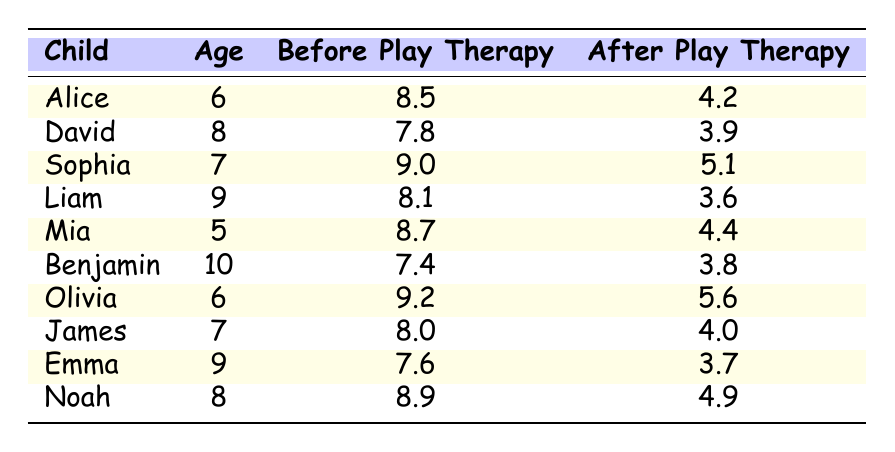What was Alice's stress level before play therapy? Alice's stress level before play therapy is directly listed in the table as 8.5.
Answer: 8.5 What is the stress level of David after play therapy? The stress level after play therapy for David can be found in the "After Play Therapy" column and is noted as 3.9.
Answer: 3.9 Which child had the highest stress level before play therapy? To find the child with the highest stress level before therapy, we can compare the "Before Play Therapy" values. Sophia has the highest value at 9.0.
Answer: Sophia What is the difference in stress levels for Liam before and after play therapy? To calculate the difference, we subtract Liam's "After Play Therapy" value of 3.6 from his "Before Play Therapy" value of 8.1: 8.1 - 3.6 = 4.5.
Answer: 4.5 Is Mia's stress level after play therapy lower than Noah's stress level before play therapy? Mia's stress level after therapy is 4.4, while Noah's stress level before therapy is 8.9. Since 4.4 is less than 8.9, the answer is yes.
Answer: Yes What was the average stress level of all children before play therapy? To find the average, sum all "Before Play Therapy" values (8.5 + 7.8 + 9.0 + 8.1 + 8.7 + 7.4 + 9.2 + 8.0 + 7.6 + 8.9 = 81.2) and divide by the number of children (10): 81.2 / 10 = 8.12.
Answer: 8.12 Which child showed the greatest improvement in stress levels after play therapy? To find the greatest improvement, calculate the difference for each child by subtracting the "After Play Therapy" value from the "Before Play Therapy" value. The highest difference corresponds to Alice (8.5 - 4.2 = 4.3).
Answer: Alice Did any child have the same stress level before and after play therapy? We check each child's before and after values; none of them show the same values, indicating the answer is no.
Answer: No 